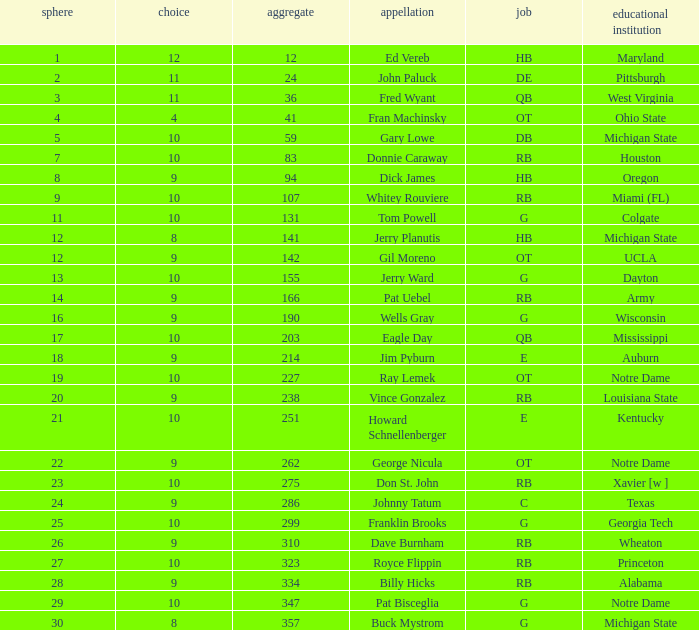What is the sum of rounds that has a pick of 9 and is named jim pyburn? 18.0. 